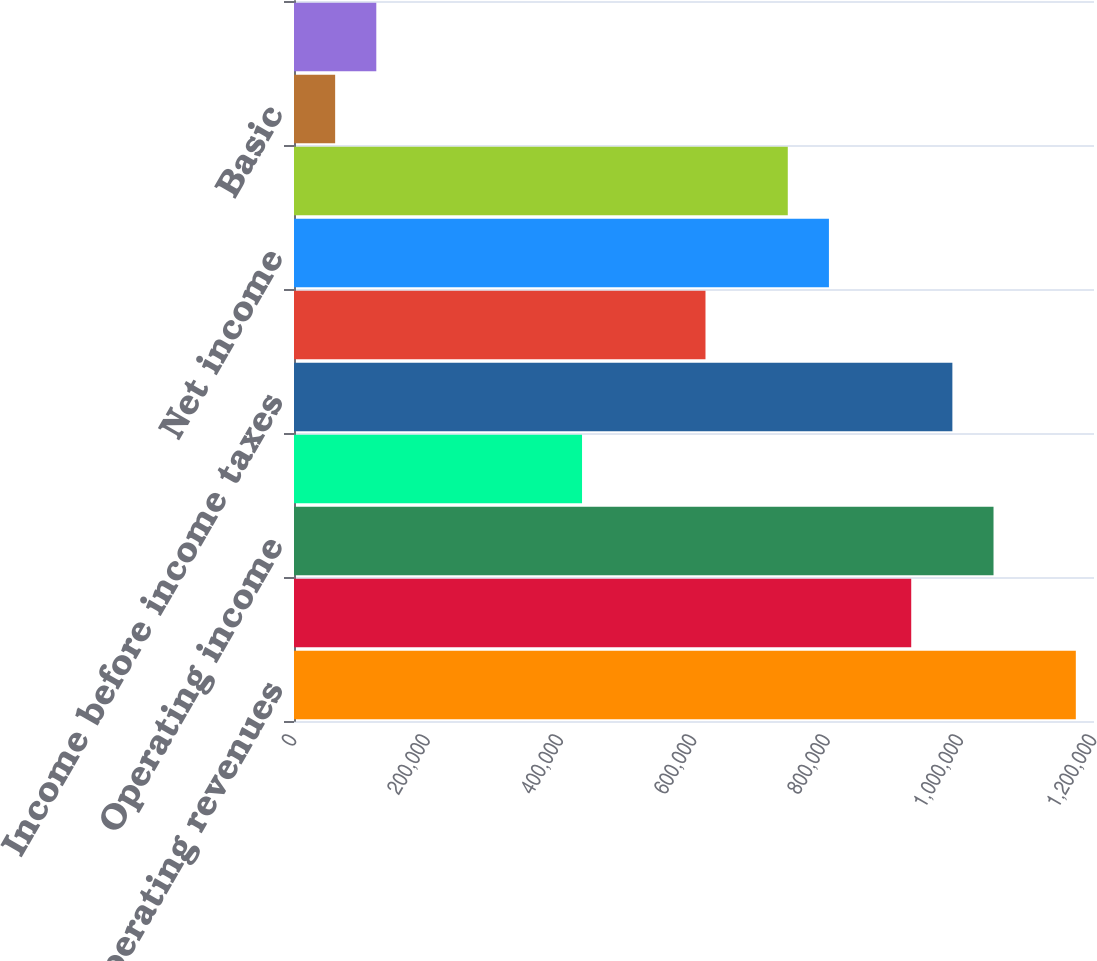<chart> <loc_0><loc_0><loc_500><loc_500><bar_chart><fcel>Total operating revenues<fcel>Total operating expenses<fcel>Operating income<fcel>Total other income/(expense)<fcel>Income before income taxes<fcel>Income tax provision<fcel>Net income<fcel>Net income allocated to common<fcel>Basic<fcel>Diluted<nl><fcel>1.17273e+06<fcel>925837<fcel>1.04928e+06<fcel>432058<fcel>987560<fcel>617225<fcel>802392<fcel>740670<fcel>61723.2<fcel>123446<nl></chart> 